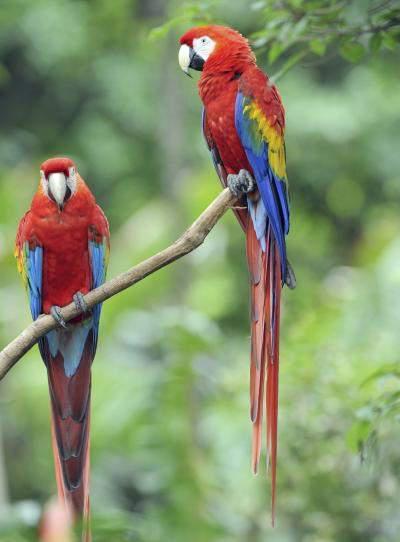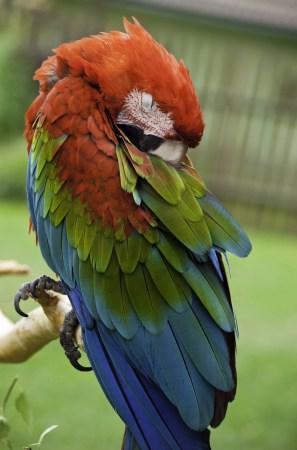The first image is the image on the left, the second image is the image on the right. Examine the images to the left and right. Is the description "The left image contains two parrots perched on a branch." accurate? Answer yes or no. Yes. 